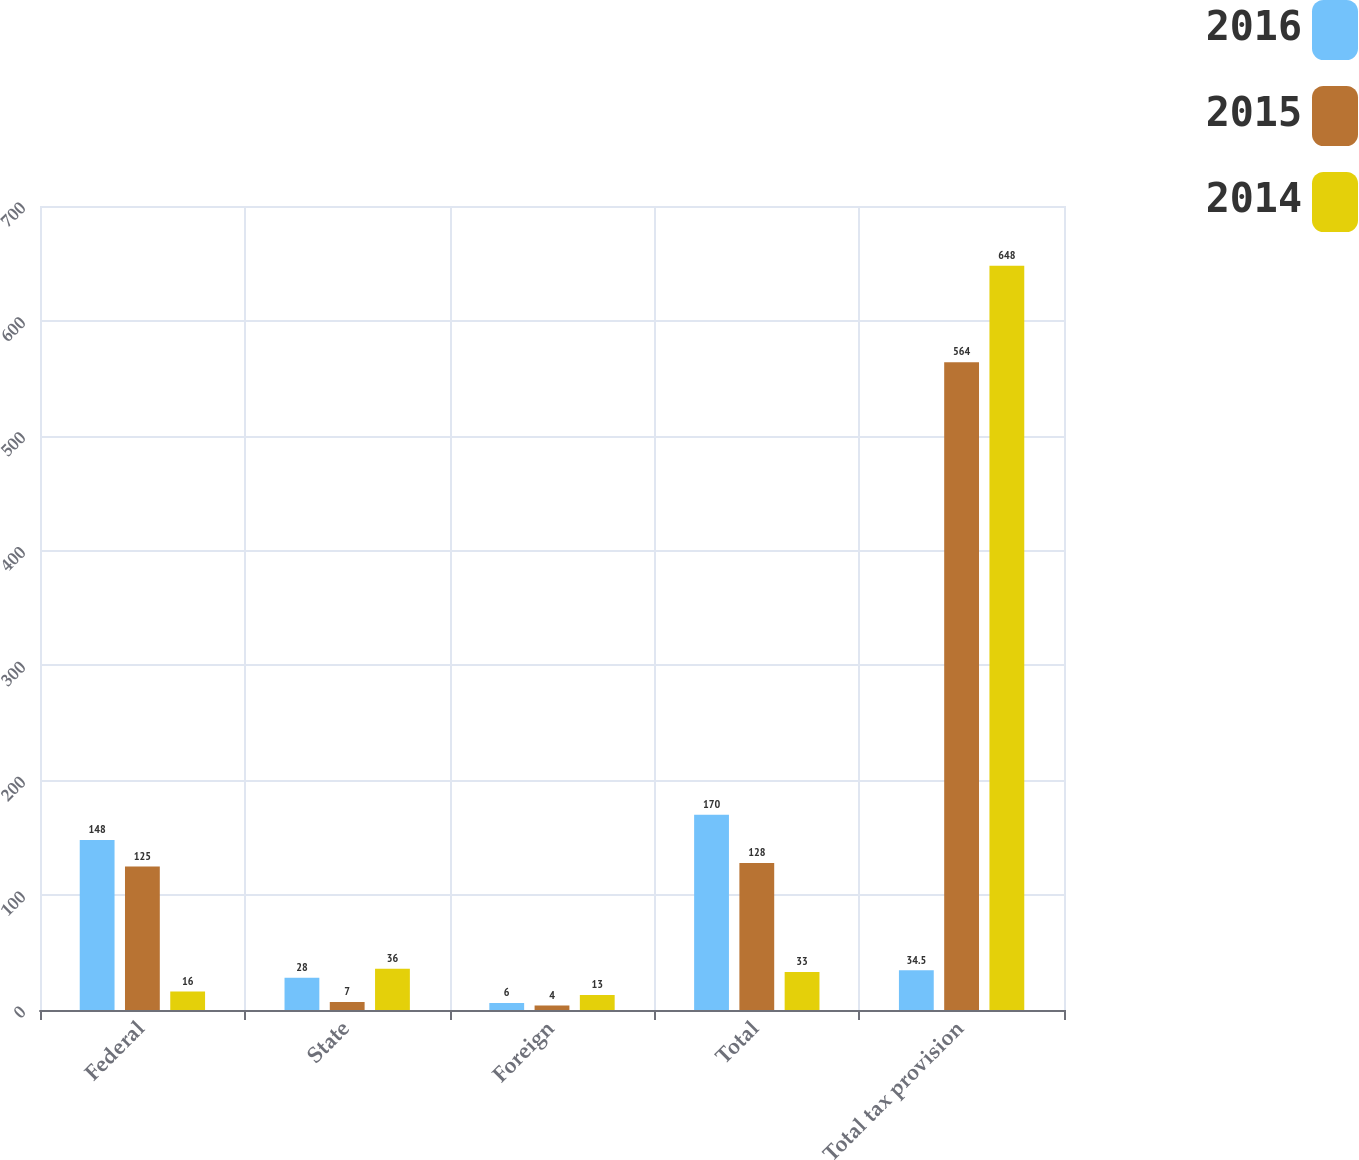Convert chart. <chart><loc_0><loc_0><loc_500><loc_500><stacked_bar_chart><ecel><fcel>Federal<fcel>State<fcel>Foreign<fcel>Total<fcel>Total tax provision<nl><fcel>2016<fcel>148<fcel>28<fcel>6<fcel>170<fcel>34.5<nl><fcel>2015<fcel>125<fcel>7<fcel>4<fcel>128<fcel>564<nl><fcel>2014<fcel>16<fcel>36<fcel>13<fcel>33<fcel>648<nl></chart> 